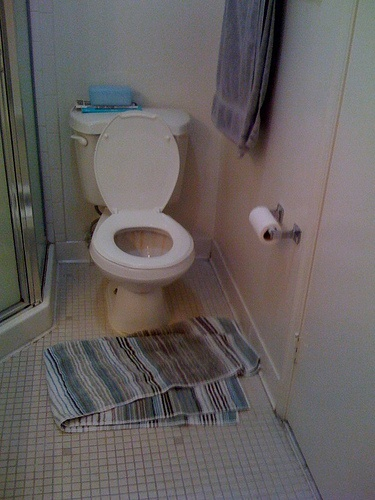Describe the objects in this image and their specific colors. I can see toilet in black, darkgray, gray, and maroon tones, book in black, gray, blue, and darkblue tones, and book in black, teal, darkblue, and blue tones in this image. 